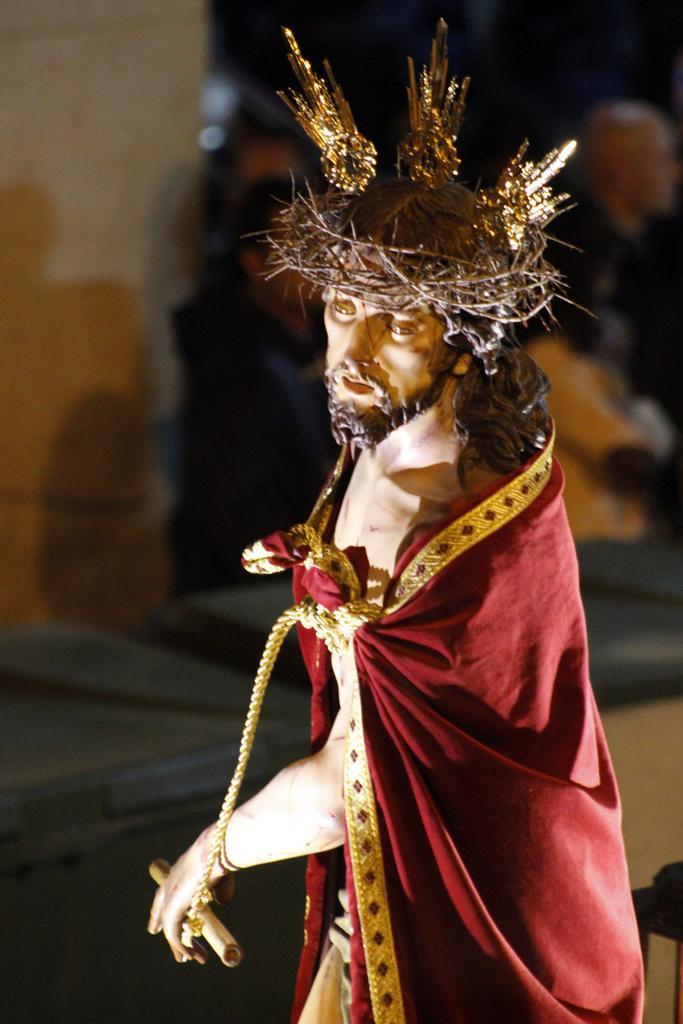Can you describe this image briefly? In the image there is a statue of a person with thrones crown on head and a cloth over his body and behind it seems to be few persons standing. 